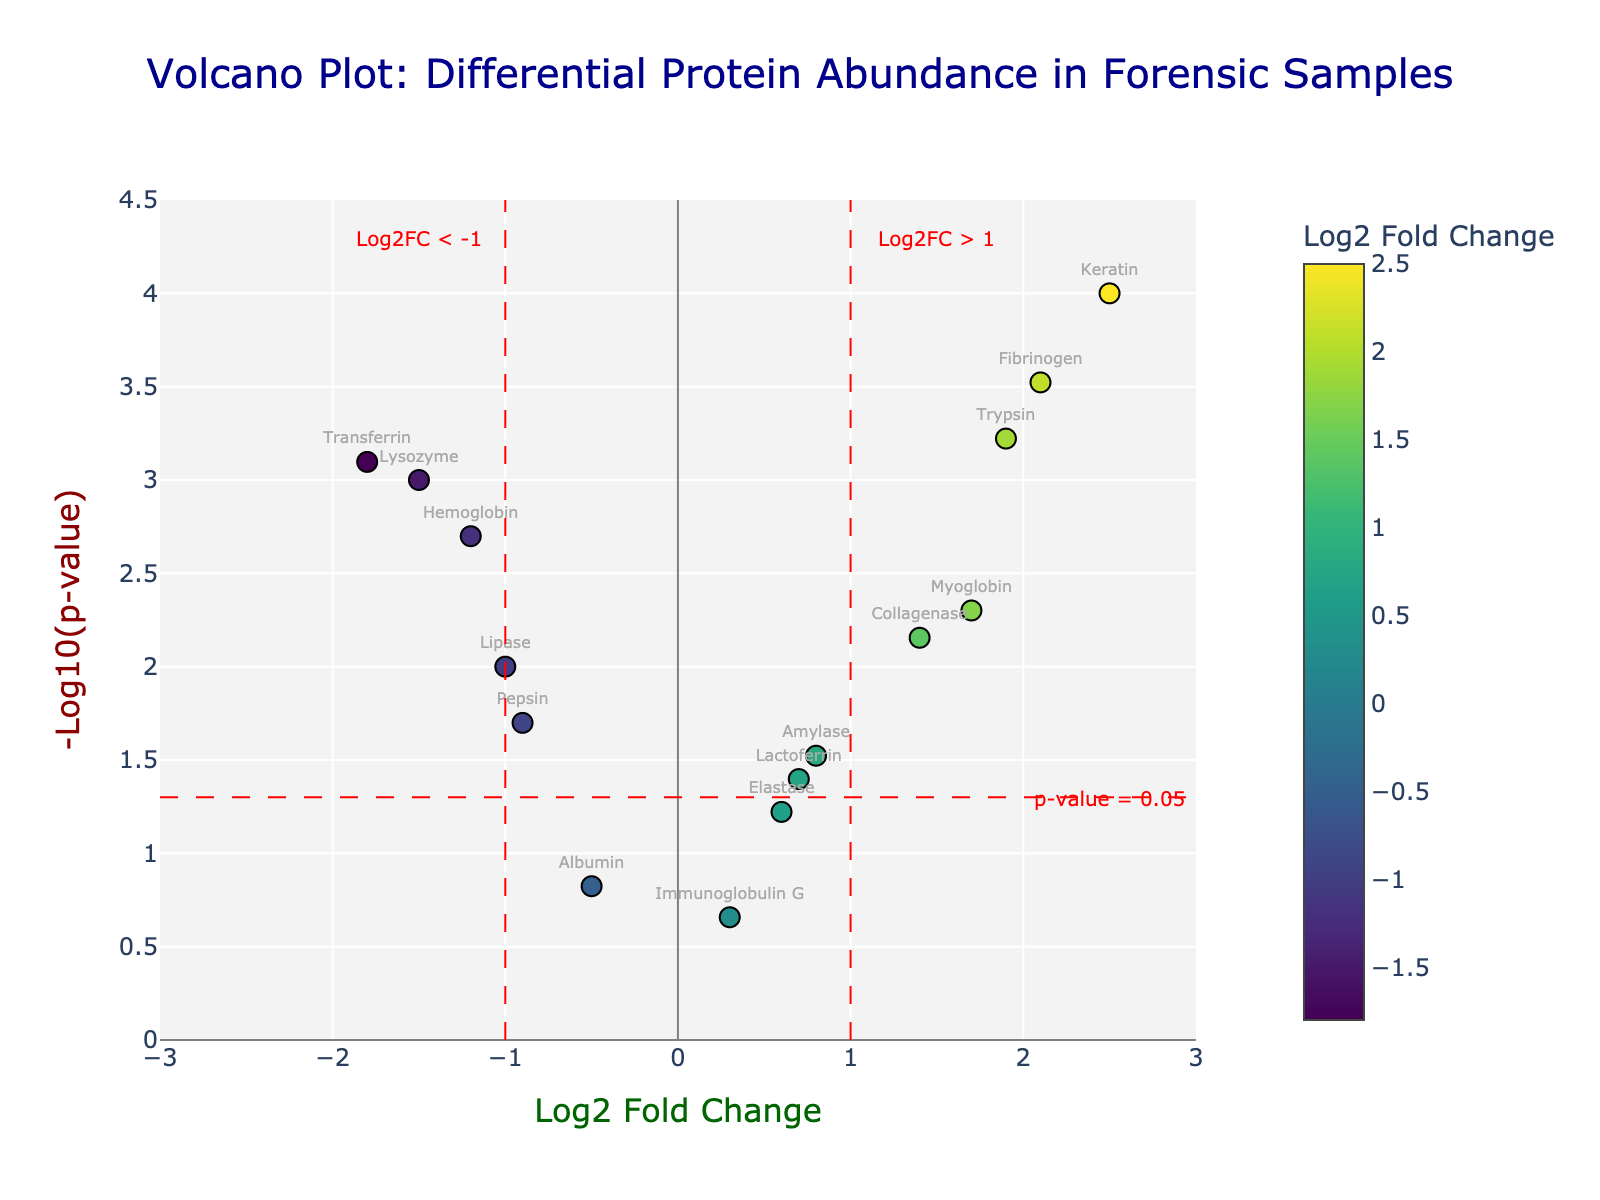What's the title of the plot? The title of the plot can be found at the top of the figure.
Answer: Volcano Plot: Differential Protein Abundance in Forensic Samples How many proteins show a Log2 Fold Change greater than 1? Identify data points to the right of the vertical line at Log2FC = 1. There are 4 such points.
Answer: 4 Which protein has the highest Log2 Fold Change? Look for the protein with the highest value on the x-axis. It's Keratin with a Log2FC of 2.5.
Answer: Keratin What is the p-value threshold for significance, and how is it represented? The p-value threshold of 0.05 is shown by a horizontal red line at -Log10(p) = -Log10(0.05), approximately 1.3.
Answer: 0.05 Which protein is the most statistically significant? The most statistically significant protein is the one with the highest -Log10(p-value), which is the highest point on the y-axis. It’s Keratin.
Answer: Keratin How many proteins have both a Log2 Fold Change greater than 1 and a p-value less than 0.05? Focus on the region right of the Log2FC = 1 line and above -Log10(0.05). There are 3 proteins: Keratin, Fibrinogen, and Trypsin.
Answer: 3 Identify a protein with a negative Log2 Fold Change that is also statistically significant. Look for points left of -1 on the x-axis and above the -Log10(0.05) threshold. Transferrin (log2FC = -1.8, p = 0.0008) and Hemoglobin (log2FC = -1.2, p = 0.002) fit this criteria.
Answer: Transferrin or Hemoglobin Which protein has the lowest Log2 Fold Change? Lowest log2FC means the furthest left on the x-axis. Transferrin, with a Log2FC of -1.8, has the lowest value.
Answer: Transferrin Are there any proteins with a Log2 Fold Change between -1 and 1 that are statistically significant? Focus on points between -1 and 1 on the x-axis and above -Log10(0.05). Myoglobin and Collagenase fit this criteria.
Answer: Myoglobin, Collagenase What do the different colors of the points represent? The colors on the points represent their Log2 Fold Change values, with a color scale to indicate different ranges.
Answer: Log2 Fold Change 